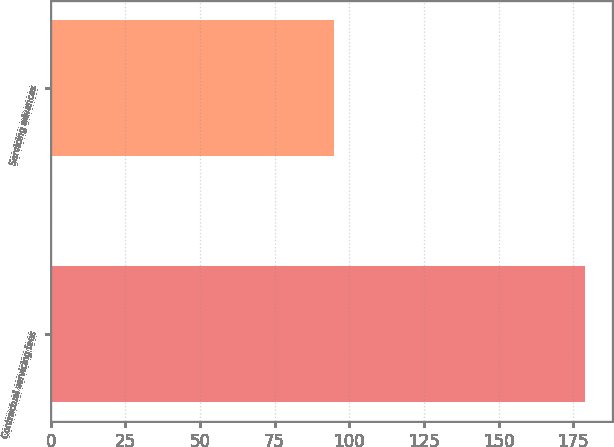<chart> <loc_0><loc_0><loc_500><loc_500><bar_chart><fcel>Contractual servicing fees<fcel>Servicing advances<nl><fcel>179<fcel>95<nl></chart> 